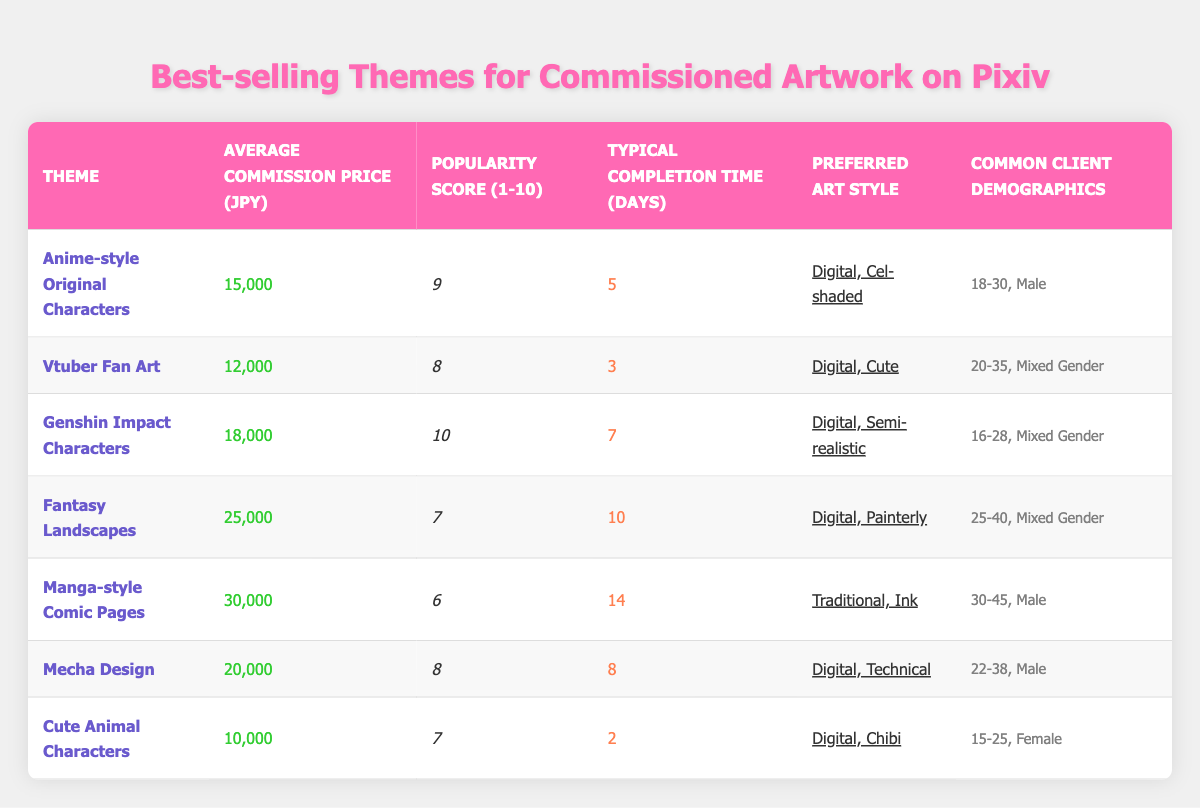What is the average commission price for Vtuber Fan Art? The table indicates that the Average Commission Price for Vtuber Fan Art is listed as 12,000 JPY.
Answer: 12,000 JPY Which theme has the highest popularity score? From the data, Genshin Impact Characters has a popularity score of 10, which is the highest among all themes presented in the table.
Answer: Genshin Impact Characters How many days does it typically take to complete a Cute Animal Characters commission? The Typical Completion Time for Cute Animal Characters as per the table is 2 days.
Answer: 2 days What is the difference in average commission price between Fantasy Landscapes and Mecha Design? The Average Commission Price for Fantasy Landscapes is 25,000 JPY and Mecha Design is 20,000 JPY. The difference is calculated as 25,000 - 20,000 = 5,000 JPY.
Answer: 5,000 JPY Are there more themes with a popularity score of 7 or above? According to the table, there are four themes with a popularity score of 7 or above: Anime-style Original Characters, Vtuber Fan Art, Genshin Impact Characters, and Mecha Design. Therefore, the answer is yes.
Answer: Yes What is the average commission price for themes preferred by clients aged 20-35? The themes that fall under the demographic of 20-35 are Vtuber Fan Art (12,000 JPY) and Genshin Impact Characters (18,000 JPY). To find the average, we calculate (12,000 + 18,000) / 2 = 15,000 JPY.
Answer: 15,000 JPY How many themes typically require more than 10 days for completion? By examining the table, only Fantasy Landscapes takes 10 days for completion, while Manga-style Comic Pages takes 14 days. Therefore, there are two themes that require more than 10 days.
Answer: 2 themes Which theme has the lowest average commission price and what is it? Looking at the Average Commission Price column, the theme with the lowest price is Cute Animal Characters at 10,000 JPY.
Answer: Cute Animal Characters, 10,000 JPY 